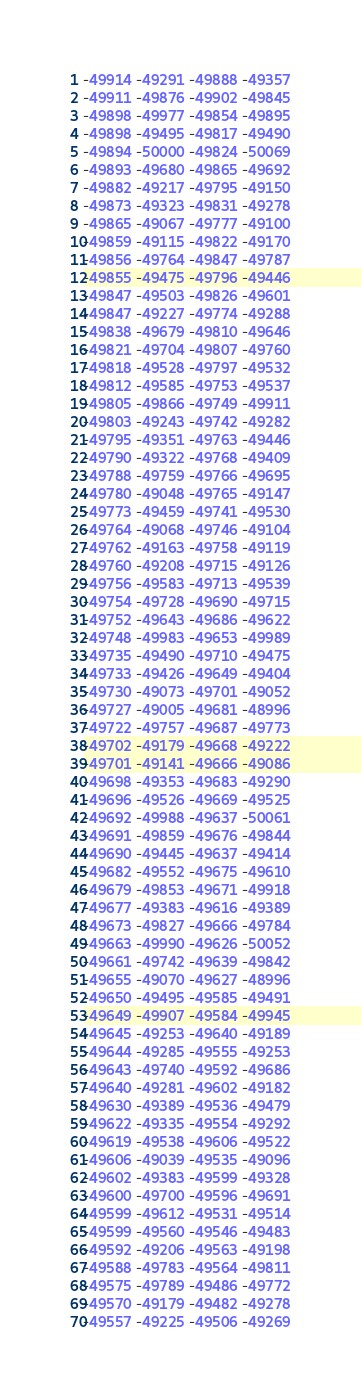<code> <loc_0><loc_0><loc_500><loc_500><_Rust_>-49914 -49291 -49888 -49357
-49911 -49876 -49902 -49845
-49898 -49977 -49854 -49895
-49898 -49495 -49817 -49490
-49894 -50000 -49824 -50069
-49893 -49680 -49865 -49692
-49882 -49217 -49795 -49150
-49873 -49323 -49831 -49278
-49865 -49067 -49777 -49100
-49859 -49115 -49822 -49170
-49856 -49764 -49847 -49787
-49855 -49475 -49796 -49446
-49847 -49503 -49826 -49601
-49847 -49227 -49774 -49288
-49838 -49679 -49810 -49646
-49821 -49704 -49807 -49760
-49818 -49528 -49797 -49532
-49812 -49585 -49753 -49537
-49805 -49866 -49749 -49911
-49803 -49243 -49742 -49282
-49795 -49351 -49763 -49446
-49790 -49322 -49768 -49409
-49788 -49759 -49766 -49695
-49780 -49048 -49765 -49147
-49773 -49459 -49741 -49530
-49764 -49068 -49746 -49104
-49762 -49163 -49758 -49119
-49760 -49208 -49715 -49126
-49756 -49583 -49713 -49539
-49754 -49728 -49690 -49715
-49752 -49643 -49686 -49622
-49748 -49983 -49653 -49989
-49735 -49490 -49710 -49475
-49733 -49426 -49649 -49404
-49730 -49073 -49701 -49052
-49727 -49005 -49681 -48996
-49722 -49757 -49687 -49773
-49702 -49179 -49668 -49222
-49701 -49141 -49666 -49086
-49698 -49353 -49683 -49290
-49696 -49526 -49669 -49525
-49692 -49988 -49637 -50061
-49691 -49859 -49676 -49844
-49690 -49445 -49637 -49414
-49682 -49552 -49675 -49610
-49679 -49853 -49671 -49918
-49677 -49383 -49616 -49389
-49673 -49827 -49666 -49784
-49663 -49990 -49626 -50052
-49661 -49742 -49639 -49842
-49655 -49070 -49627 -48996
-49650 -49495 -49585 -49491
-49649 -49907 -49584 -49945
-49645 -49253 -49640 -49189
-49644 -49285 -49555 -49253
-49643 -49740 -49592 -49686
-49640 -49281 -49602 -49182
-49630 -49389 -49536 -49479
-49622 -49335 -49554 -49292
-49619 -49538 -49606 -49522
-49606 -49039 -49535 -49096
-49602 -49383 -49599 -49328
-49600 -49700 -49596 -49691
-49599 -49612 -49531 -49514
-49599 -49560 -49546 -49483
-49592 -49206 -49563 -49198
-49588 -49783 -49564 -49811
-49575 -49789 -49486 -49772
-49570 -49179 -49482 -49278
-49557 -49225 -49506 -49269</code> 